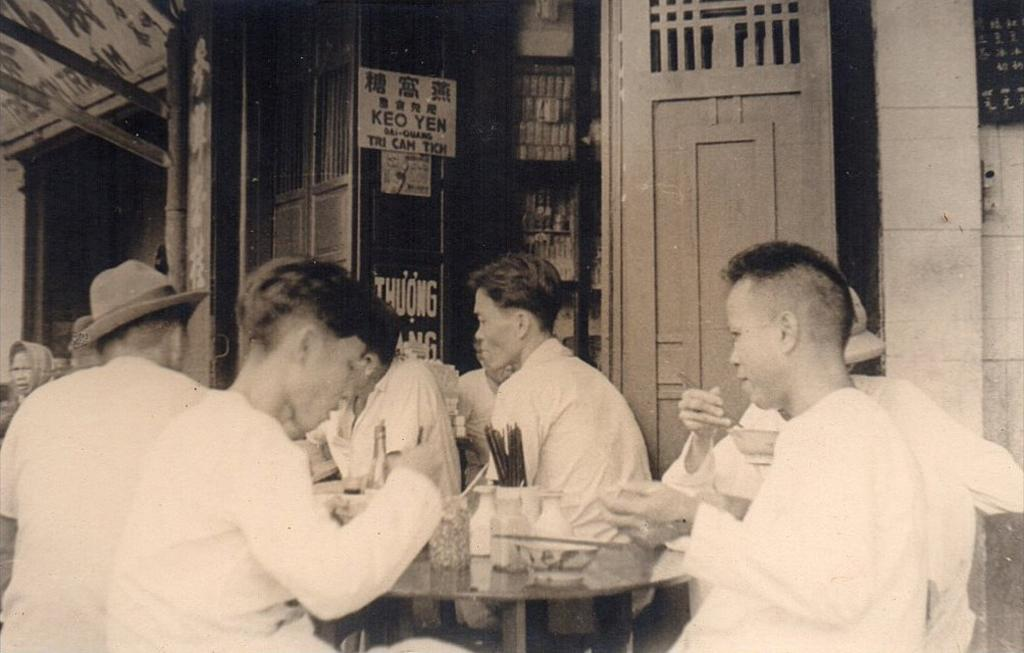What is the color scheme of the image? The image is black and white. What are the people in the image doing? The people are sitting on chairs in the image. What can be seen in the background of the image? There is a house and boards with text in the background of the image. What features does the house have? The house has doors. What type of plate is being used by the people in the image? There is no plate visible in the image; the people are sitting on chairs. How does the image start to convey its message? The image does not have a specific starting point, as it is a static image. 